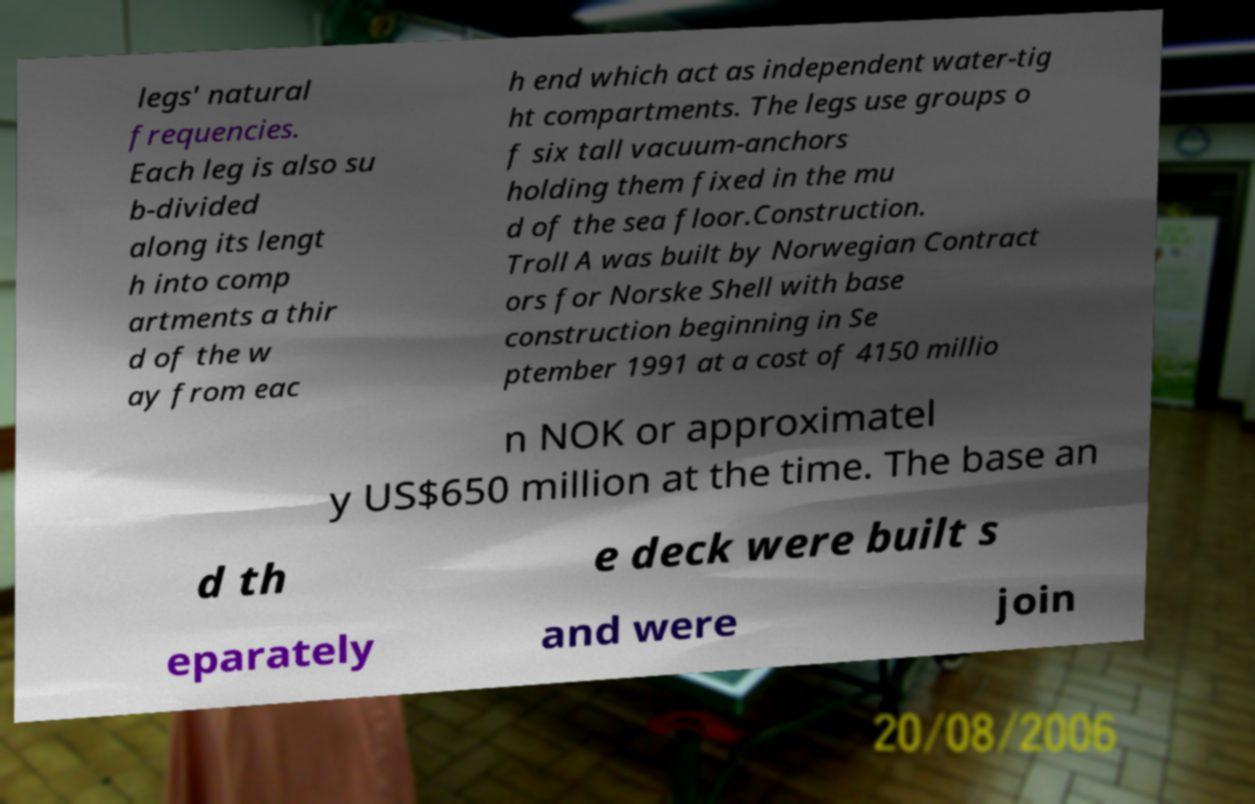Please identify and transcribe the text found in this image. legs' natural frequencies. Each leg is also su b-divided along its lengt h into comp artments a thir d of the w ay from eac h end which act as independent water-tig ht compartments. The legs use groups o f six tall vacuum-anchors holding them fixed in the mu d of the sea floor.Construction. Troll A was built by Norwegian Contract ors for Norske Shell with base construction beginning in Se ptember 1991 at a cost of 4150 millio n NOK or approximatel y US$650 million at the time. The base an d th e deck were built s eparately and were join 